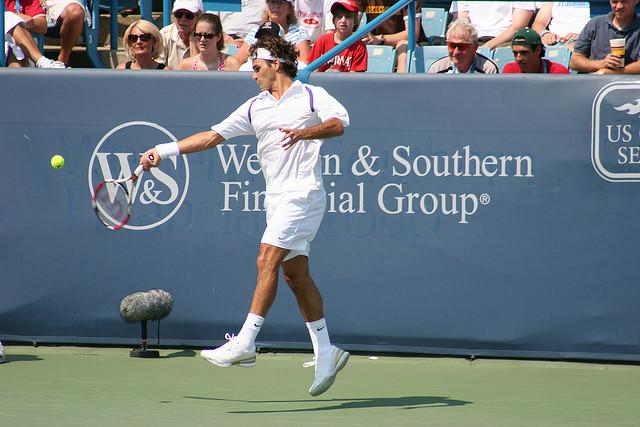What is traveling towards the man? tennis ball 